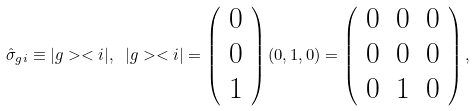Convert formula to latex. <formula><loc_0><loc_0><loc_500><loc_500>\hat { \sigma } _ { g i } \equiv | g > < i | , \text { } | g > < i | = \left ( \begin{array} { c c c c } 0 \\ 0 \\ 1 \end{array} \right ) ( 0 , 1 , 0 ) = \left ( \begin{array} { c c c c } 0 & 0 & 0 \\ 0 & 0 & 0 \\ 0 & 1 & 0 \end{array} \right ) ,</formula> 